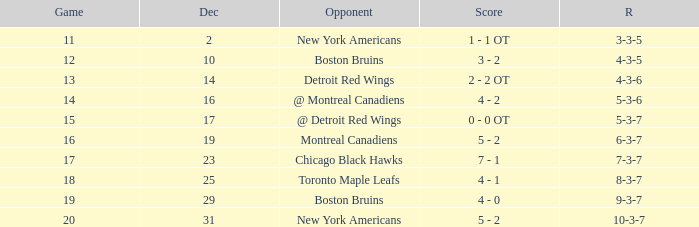Which Game is the highest one that has a Record of 4-3-6? 13.0. Parse the full table. {'header': ['Game', 'Dec', 'Opponent', 'Score', 'R'], 'rows': [['11', '2', 'New York Americans', '1 - 1 OT', '3-3-5'], ['12', '10', 'Boston Bruins', '3 - 2', '4-3-5'], ['13', '14', 'Detroit Red Wings', '2 - 2 OT', '4-3-6'], ['14', '16', '@ Montreal Canadiens', '4 - 2', '5-3-6'], ['15', '17', '@ Detroit Red Wings', '0 - 0 OT', '5-3-7'], ['16', '19', 'Montreal Canadiens', '5 - 2', '6-3-7'], ['17', '23', 'Chicago Black Hawks', '7 - 1', '7-3-7'], ['18', '25', 'Toronto Maple Leafs', '4 - 1', '8-3-7'], ['19', '29', 'Boston Bruins', '4 - 0', '9-3-7'], ['20', '31', 'New York Americans', '5 - 2', '10-3-7']]} 